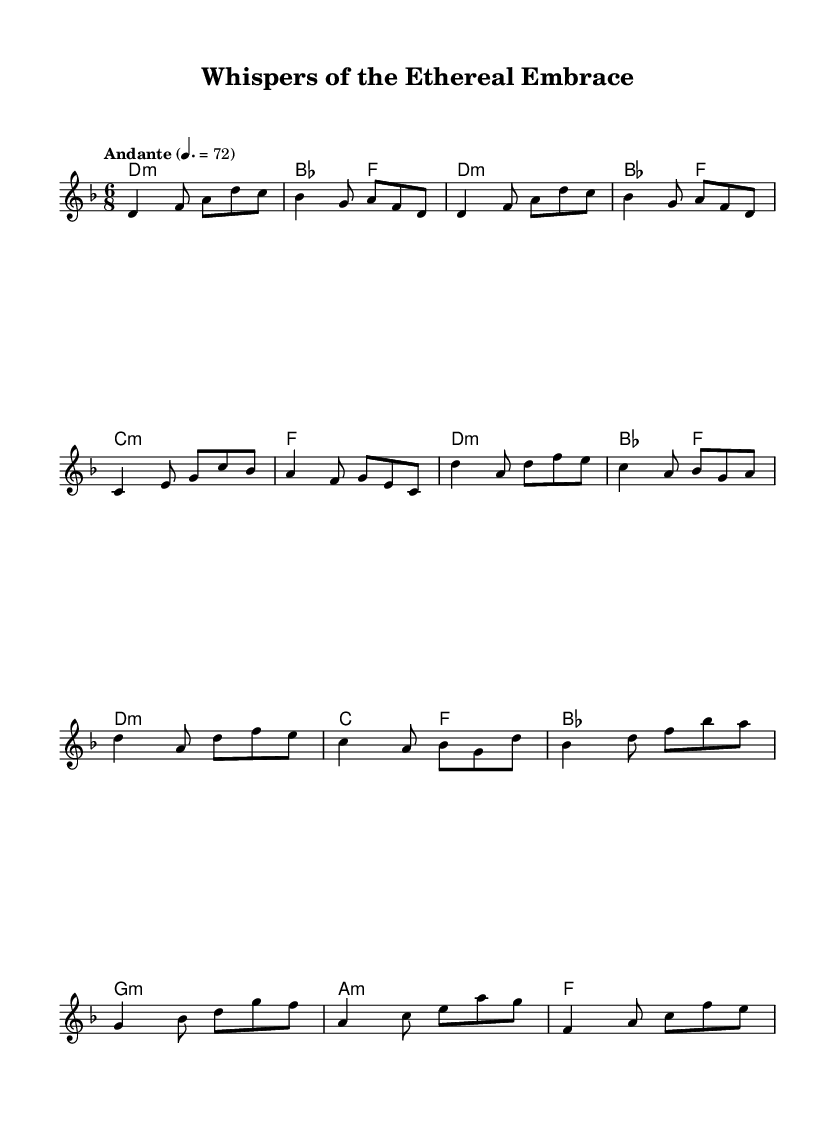What is the key signature of this music? The key signature indicated is D minor, which includes one flat (B flat) in the key signature, typically shown at the beginning of the staff.
Answer: D minor What is the time signature of this piece? The time signature at the beginning of the score is 6/8, indicating a compound time signature with six eighth notes per measure.
Answer: 6/8 What is the tempo marking for the piece? The tempo marking is "Andante," which suggests a moderate walking pace, and is indicated at the beginning of the score with a tempo of quarter note equals seventy-two beats per minute.
Answer: Andante How many measures are in the chorus section? By analyzing the measures in the score, there are four measures within the chorus section as identified in the music sheet.
Answer: 4 What is the harmonic structure of the bridge section? The bridge section consists of two measures, with chord changes to B flat major followed by G minor and A minor, each lasting for two beats with varied harmony.
Answer: B flat major, G minor, A minor What musical form does this piece follow based on structure? The piece exhibits a verse-chorus structure, as indicated by the repeated melodies in the verse and distinct musical phrases in the chorus and bridge sections.
Answer: Verse-chorus How does the style of this piece reflect folk metal elements? The use of haunting melodies, minor key signature, and thematic content focused on spectral lovers and ancient ghost stories contributes to the folk metal genre's storytelling nature.
Answer: Haunting melodies, spectral themes 